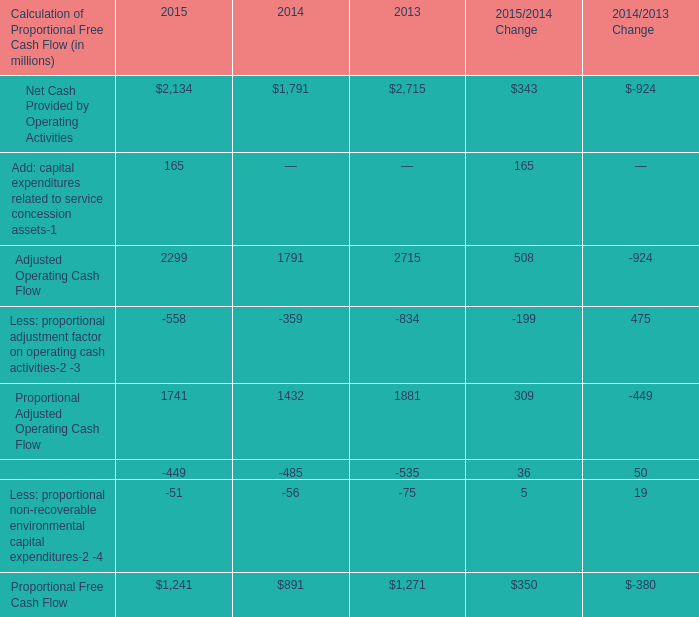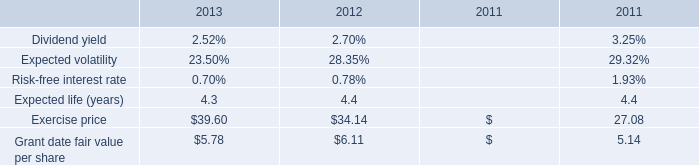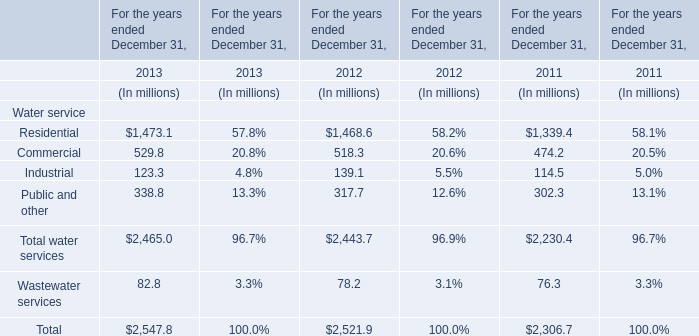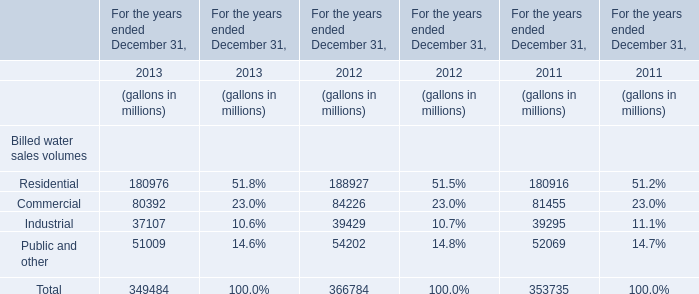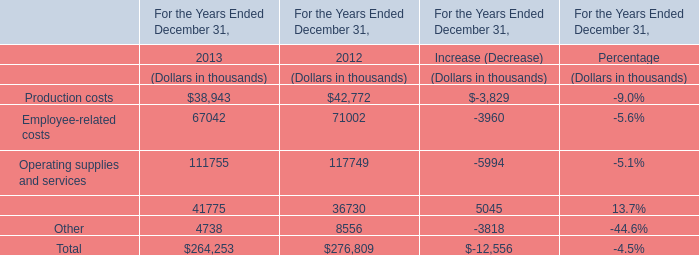What's the average of Residential in 2011,2012, and 2013? (in million) 
Computations: (((180916 + 188927) + 180976) / 3)
Answer: 183606.33333. 